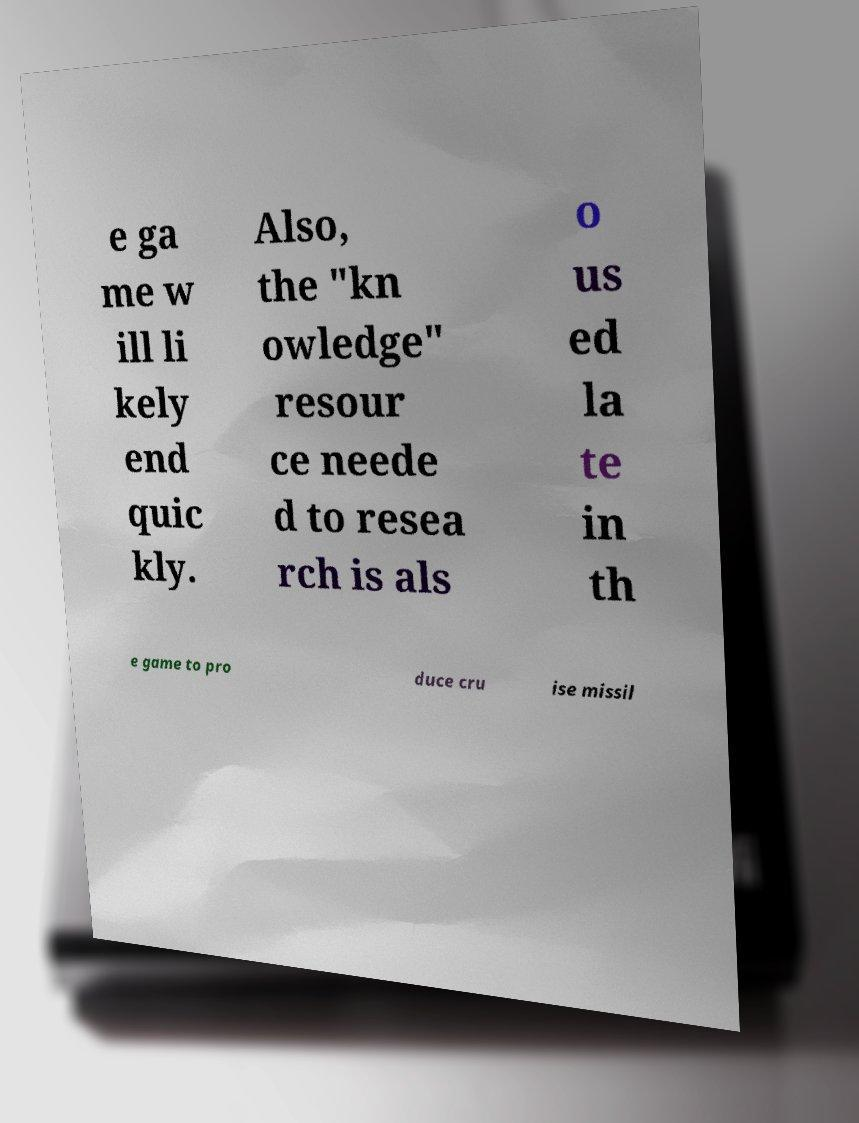Please read and relay the text visible in this image. What does it say? e ga me w ill li kely end quic kly. Also, the "kn owledge" resour ce neede d to resea rch is als o us ed la te in th e game to pro duce cru ise missil 